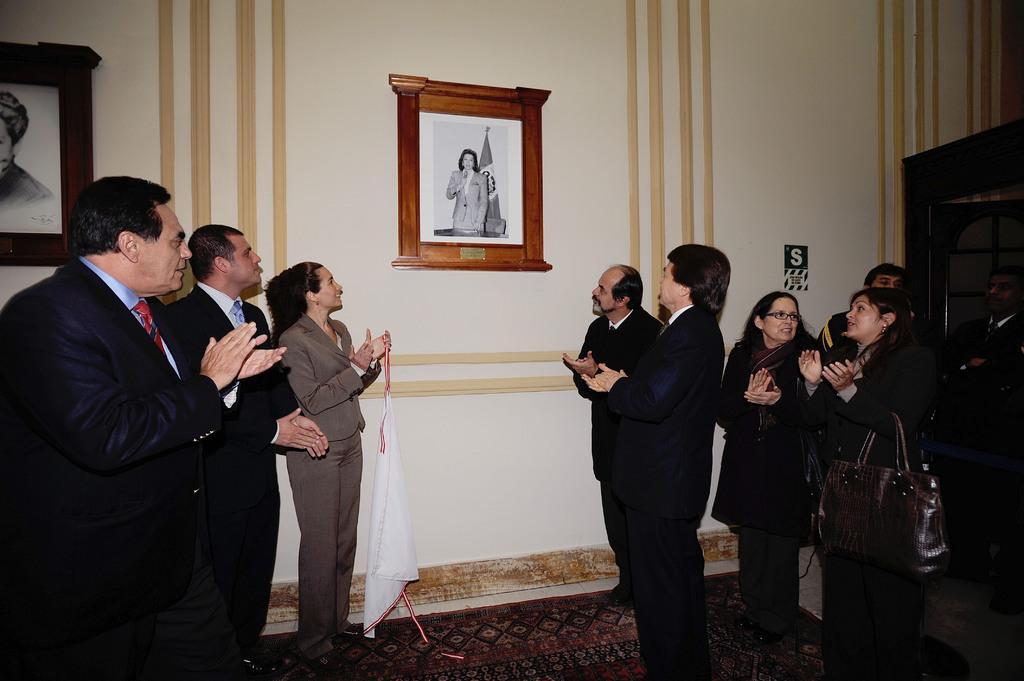How would you summarize this image in a sentence or two? In this picture I can see few people who are standing in front and I see that all of them are wearing formal dress. In the background I can see the wall, on which there are 2 photo frames and I can also see that few of them are carrying bags. 